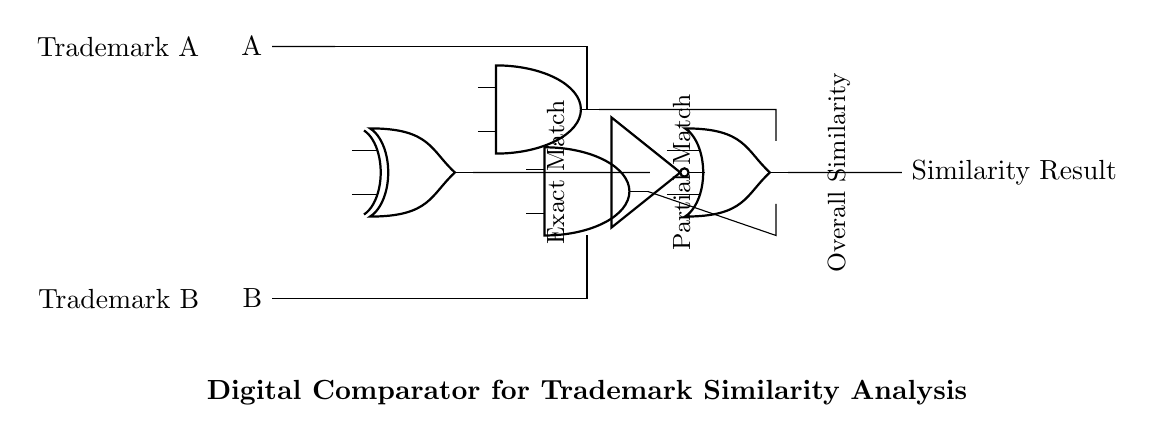What are the inputs to the circuit? The inputs to the circuit are Trademark A and Trademark B, represented as A and B in the diagram.
Answer: Trademark A and Trademark B What type of logic gate is used for the final output? The final output is produced by an OR gate, which combines the outputs from the AND gates corresponding to exact and partial matches.
Answer: OR gate How many AND gates are present in the circuit? There are two AND gates in the circuit, one for exact matches and the other for partial matches, as indicated by the labels and connections.
Answer: Two What is the output of the NOT gate? The NOT gate inverts the output of the XOR gate, which is fed into it, resulting in a false when the inputs are similar and true otherwise.
Answer: Inverted XOR output What does the label "Exact Match" indicate? The label "Exact Match" indicates that the corresponding AND gate outputs a high signal when the inputs (Trademark A and Trademark B) are exactly the same.
Answer: Exact match condition How does the circuit determine overall similarity? The circuit determines overall similarity by using the outputs from the AND gates for both exact and partial matches, which are then fed into the OR gate. If either AND gate outputs a high signal, the overall similarity is true.
Answer: Minimum one high output What is the function of the XOR gate in this circuit? The XOR gate determines if the inputs are different; it outputs a high signal when Trademark A and Trademark B are not the same. This output is used to assess similarity alongside the NOT gate's inversion.
Answer: Determine difference 